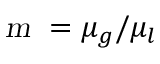<formula> <loc_0><loc_0><loc_500><loc_500>m = \mu _ { g } / \mu _ { l }</formula> 